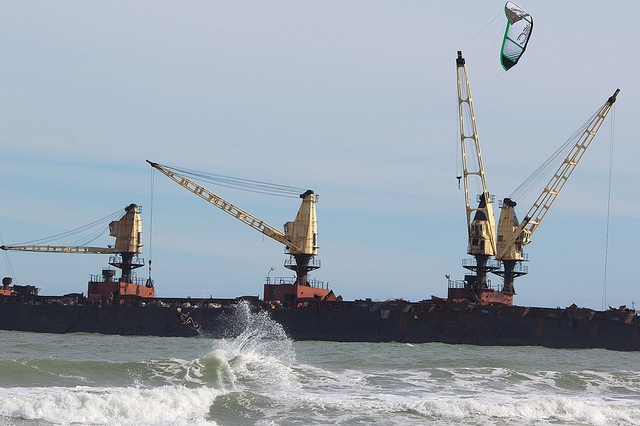Describe the objects in this image and their specific colors. I can see a kite in lightgray, lavender, darkgray, and gray tones in this image. 